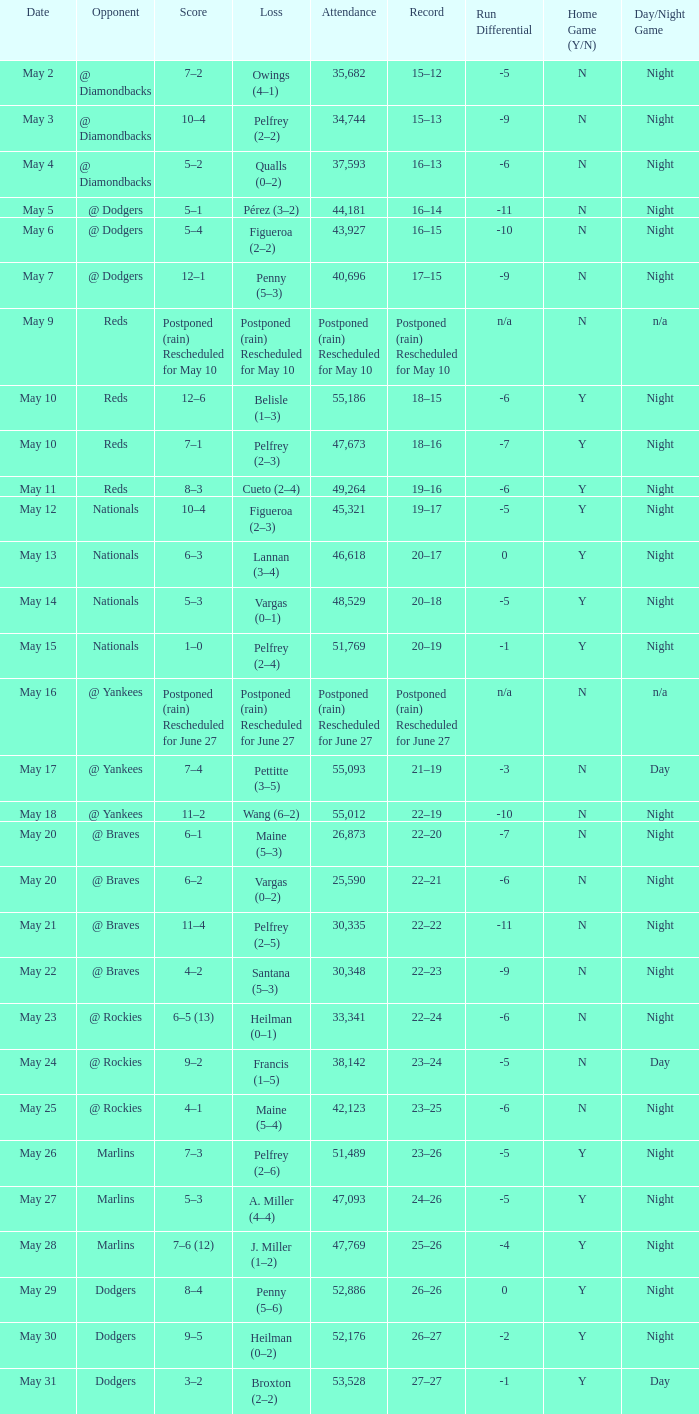Record of 19–16 occurred on what date? May 11. 